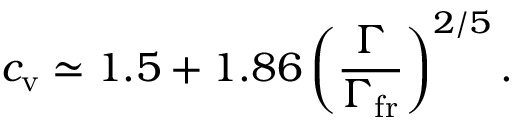<formula> <loc_0><loc_0><loc_500><loc_500>c _ { v } \simeq 1 . 5 + 1 . 8 6 \left ( \frac { \Gamma } { \Gamma _ { f r } } \right ) ^ { 2 / 5 } .</formula> 